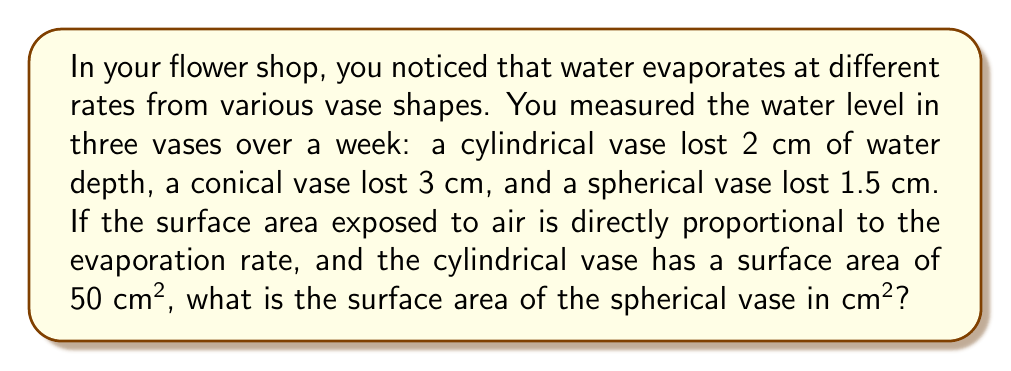Provide a solution to this math problem. Let's approach this step-by-step:

1) We know that the evaporation rate is directly proportional to the surface area exposed to air. We can express this as:

   $$ \frac{\text{Evaporation Rate}}{\text{Surface Area}} = k $$

   where $k$ is a constant.

2) For the cylindrical vase:
   $$ \frac{2 \text{ cm/week}}{50 \text{ cm}^2} = k = 0.04 \text{ cm/week/cm}^2 $$

3) Now, let's call the surface area of the spherical vase $x \text{ cm}^2$. We can set up the same proportion:

   $$ \frac{1.5 \text{ cm/week}}{x \text{ cm}^2} = 0.04 \text{ cm/week/cm}^2 $$

4) Solving for $x$:
   $$ x = \frac{1.5 \text{ cm/week}}{0.04 \text{ cm/week/cm}^2} = 37.5 \text{ cm}^2 $$

Therefore, the surface area of the spherical vase is 37.5 cm².
Answer: 37.5 cm² 